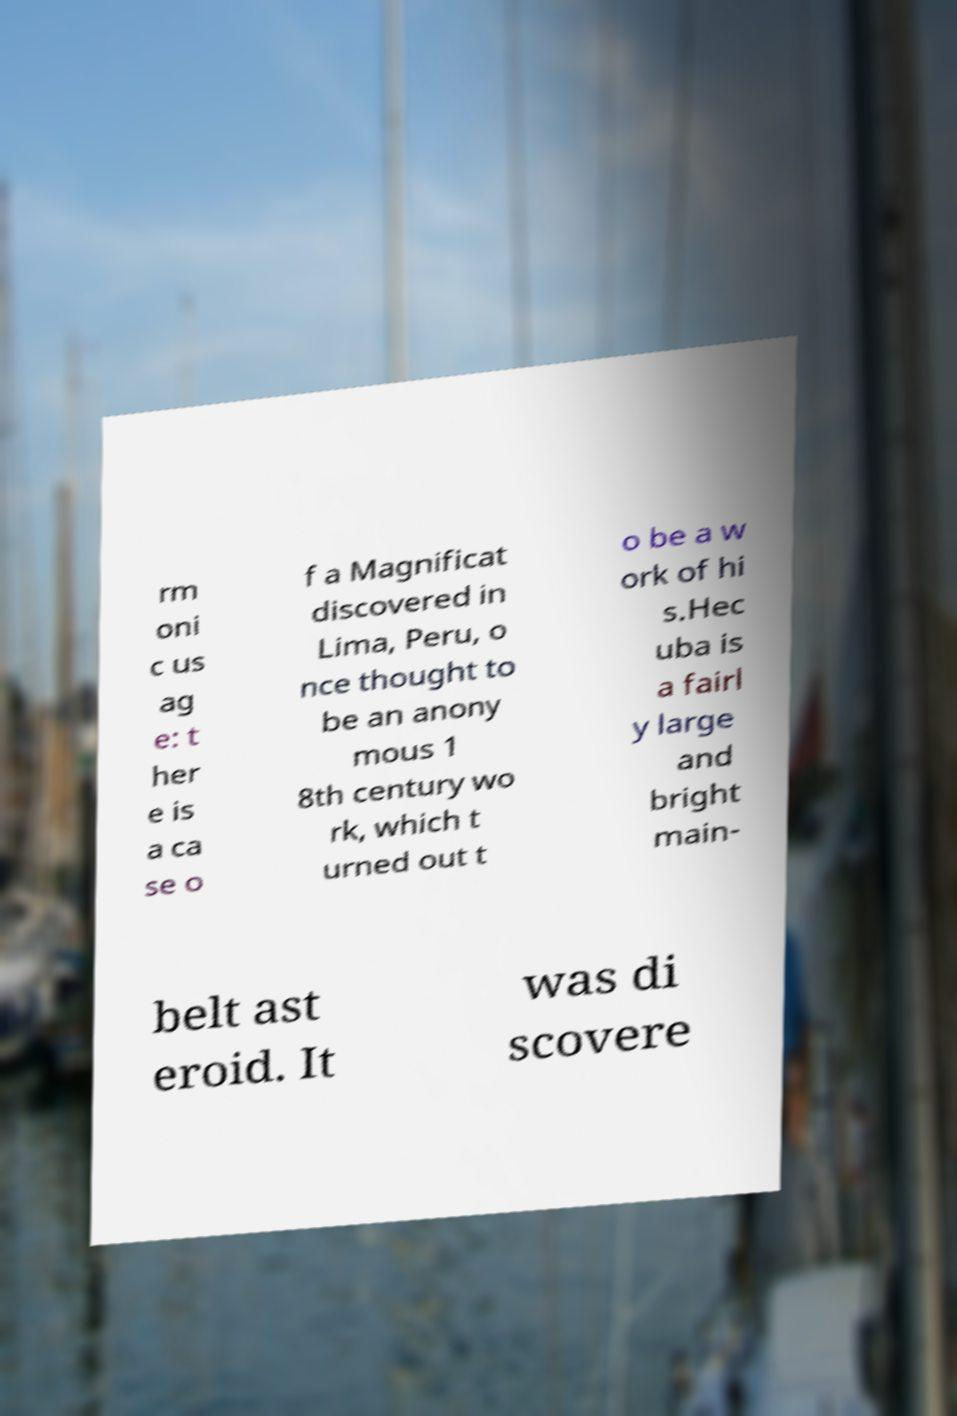Can you read and provide the text displayed in the image?This photo seems to have some interesting text. Can you extract and type it out for me? rm oni c us ag e: t her e is a ca se o f a Magnificat discovered in Lima, Peru, o nce thought to be an anony mous 1 8th century wo rk, which t urned out t o be a w ork of hi s.Hec uba is a fairl y large and bright main- belt ast eroid. It was di scovere 